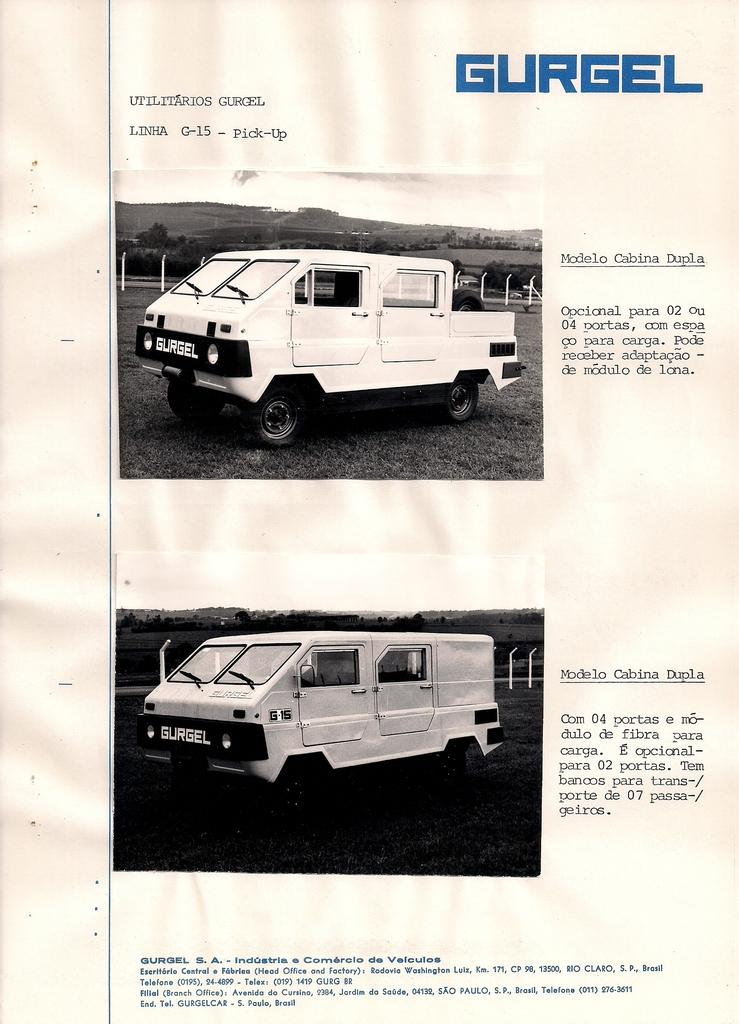What types of objects can be seen in the image? There are vehicles in the image. What kind of barrier is present in the image? There is fencing visible in the image. What type of natural elements are in the image? There are trees in the image. How is the image presented in terms of color? The image is in black and white. What type of advertisement can be seen on the trees in the image? There are no advertisements present on the trees in the image; it is in black and white and features vehicles, fencing, and trees. Are there any giants visible in the image? There are no giants present in the image; it features vehicles, fencing, and trees. 